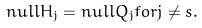Convert formula to latex. <formula><loc_0><loc_0><loc_500><loc_500>n u l l H _ { j } = n u l l Q _ { j } f o r j \neq s .</formula> 